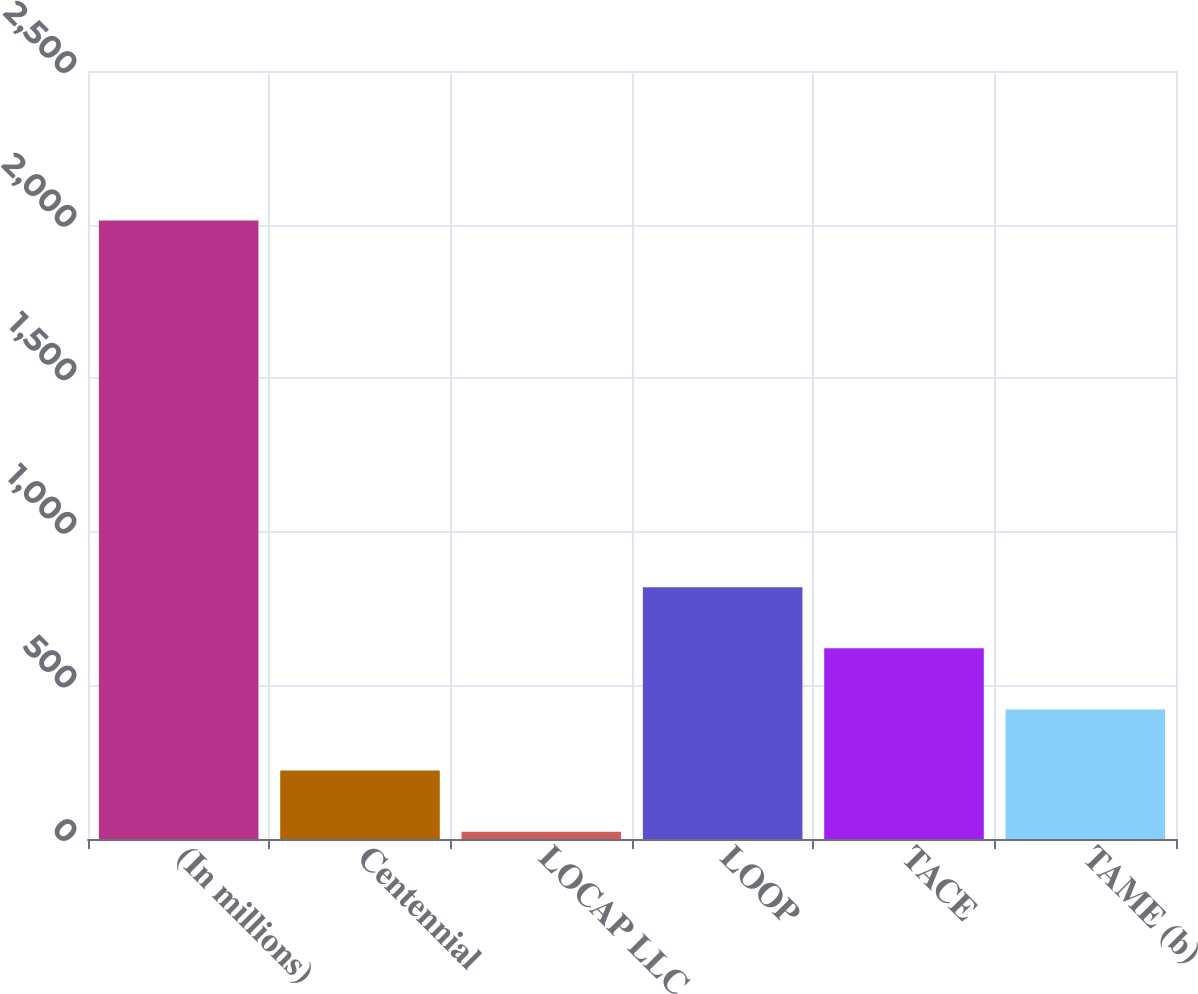Convert chart. <chart><loc_0><loc_0><loc_500><loc_500><bar_chart><fcel>(In millions)<fcel>Centennial<fcel>LOCAP LLC<fcel>LOOP<fcel>TACE<fcel>TAME (b)<nl><fcel>2013<fcel>222.9<fcel>24<fcel>819.6<fcel>620.7<fcel>421.8<nl></chart> 